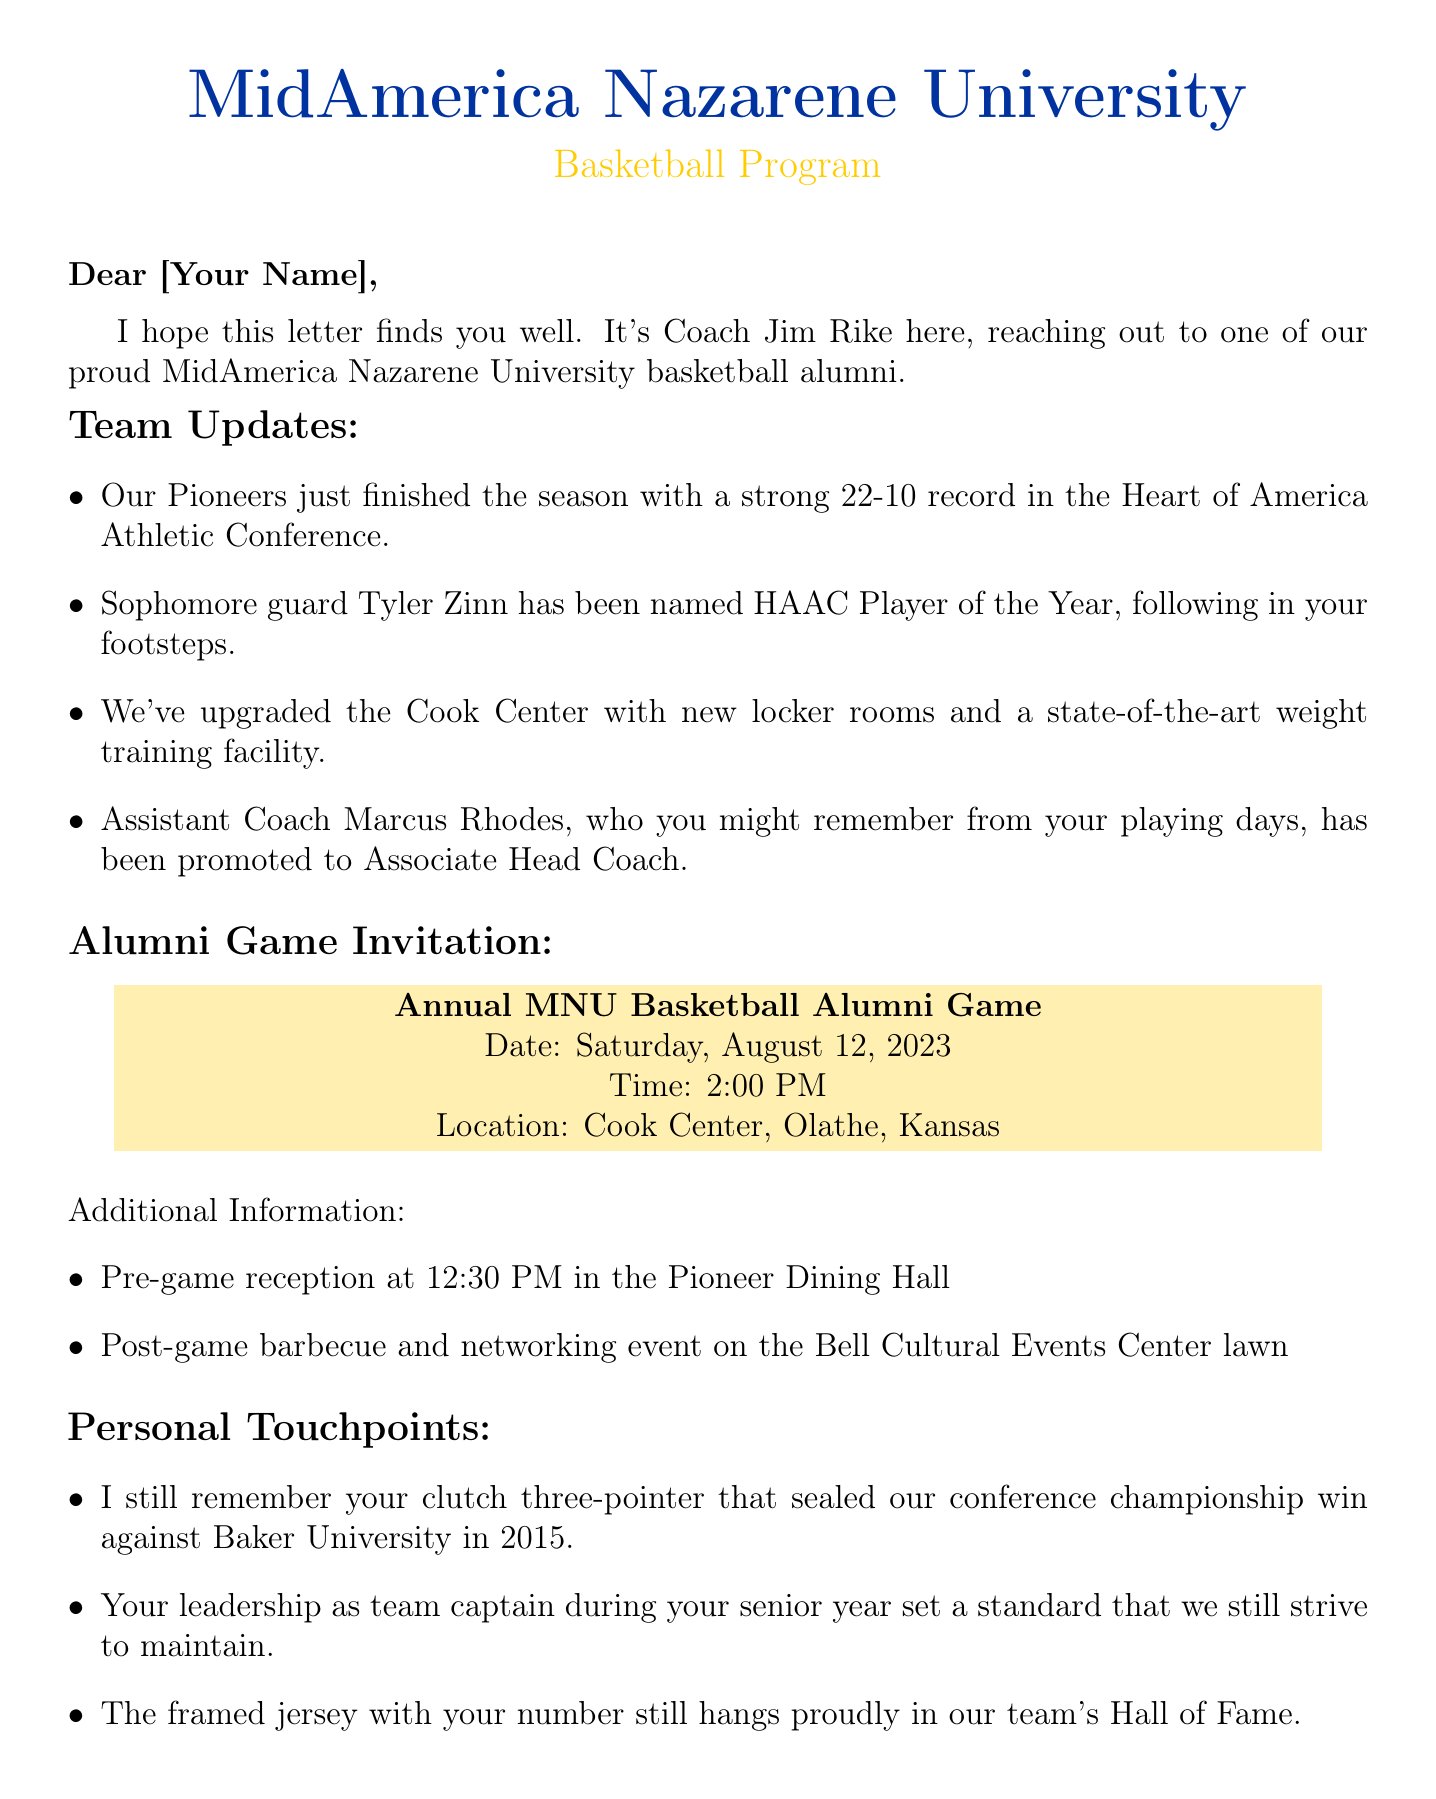What is the name of the sender? The letter is signed by Coach Jim Rike, which is indicated at the end of the document.
Answer: Coach Jim Rike What is the team's record for the season? The document states that the Pioneers finished the season with a 22-10 record in the Heart of America Athletic Conference.
Answer: 22-10 Who is the HAAC Player of the Year? The document mentions that sophomore guard Tyler Zinn has been named HAAC Player of the Year.
Answer: Tyler Zinn What date is the alumni game scheduled for? The letter specifies that the Annual MNU Basketball Alumni Game will take place on Saturday, August 12, 2023.
Answer: Saturday, August 12, 2023 What time does the pre-game reception start? The additional information section states that the pre-game reception will start at 12:30 PM.
Answer: 12:30 PM What significant memory does the coach mention about the recipient? The coach recalls the recipient's clutch three-pointer that sealed the conference championship win against Baker University in 2015.
Answer: Clutch three-pointer Who is the Athletic Department Secretary mentioned in the letter? The letter provides the name of the Athletic Department Secretary as Mrs. Linda Thompson.
Answer: Mrs. Linda Thompson What is the location of the alumni game? The document indicates that the alumni game will be held at the Cook Center, Olathe, Kansas.
Answer: Cook Center, Olathe, Kansas 